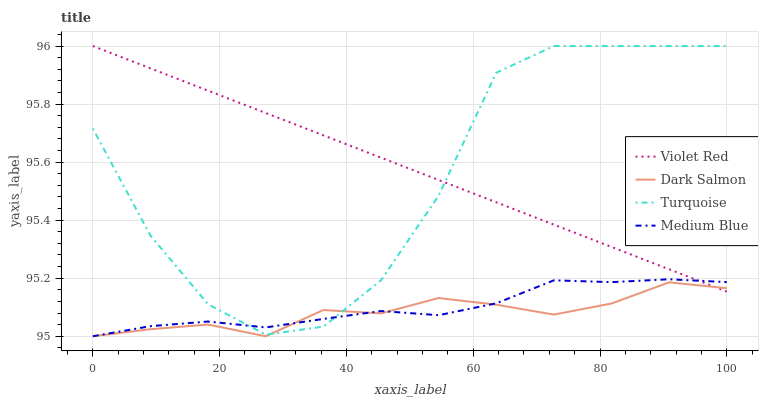Does Dark Salmon have the minimum area under the curve?
Answer yes or no. Yes. Does Violet Red have the maximum area under the curve?
Answer yes or no. Yes. Does Turquoise have the minimum area under the curve?
Answer yes or no. No. Does Turquoise have the maximum area under the curve?
Answer yes or no. No. Is Violet Red the smoothest?
Answer yes or no. Yes. Is Turquoise the roughest?
Answer yes or no. Yes. Is Medium Blue the smoothest?
Answer yes or no. No. Is Medium Blue the roughest?
Answer yes or no. No. Does Medium Blue have the lowest value?
Answer yes or no. Yes. Does Turquoise have the lowest value?
Answer yes or no. No. Does Turquoise have the highest value?
Answer yes or no. Yes. Does Medium Blue have the highest value?
Answer yes or no. No. Does Turquoise intersect Violet Red?
Answer yes or no. Yes. Is Turquoise less than Violet Red?
Answer yes or no. No. Is Turquoise greater than Violet Red?
Answer yes or no. No. 